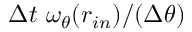Convert formula to latex. <formula><loc_0><loc_0><loc_500><loc_500>\Delta t \ \omega _ { \theta } ( r _ { i n } ) / ( \Delta \theta )</formula> 